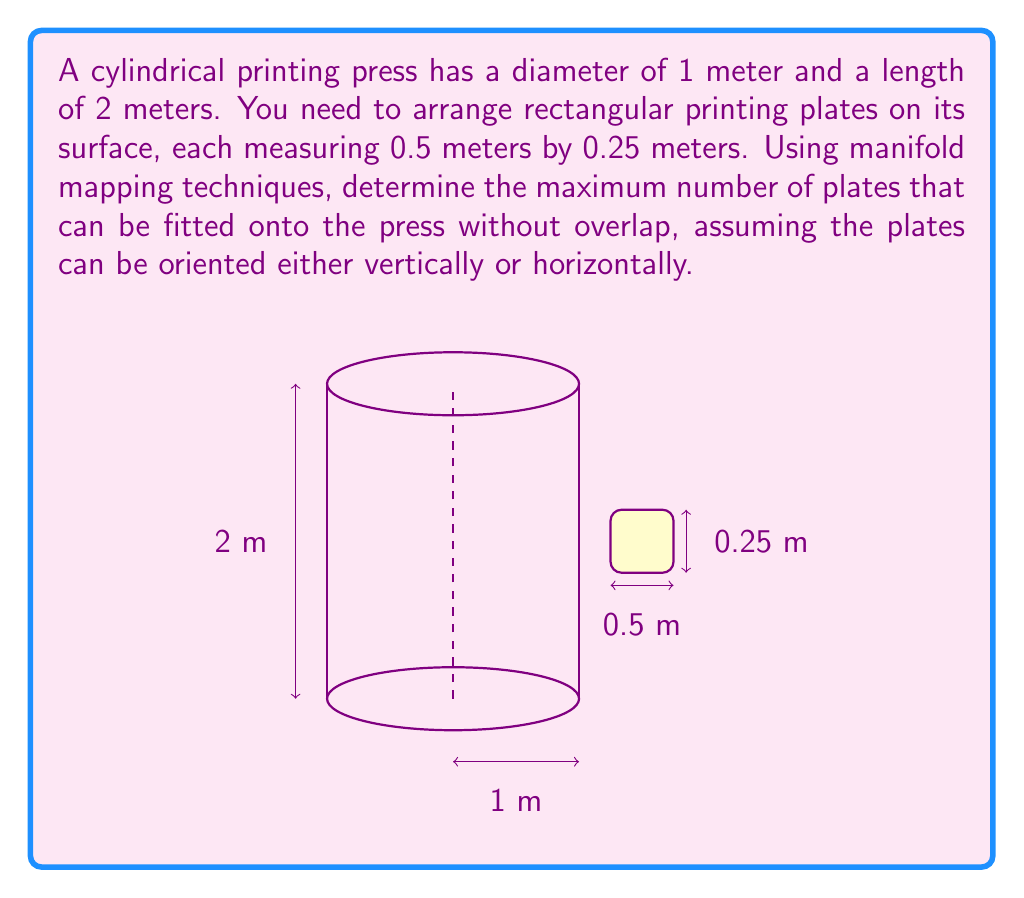Can you solve this math problem? To solve this problem, we'll use manifold mapping techniques to translate the cylindrical surface into a flat rectangular surface. Then, we'll determine the optimal arrangement of plates on this flattened surface.

Step 1: Map the cylindrical surface to a flat rectangle
The surface area of the cylinder is given by:
$$A = 2\pi rh$$
where $r$ is the radius (0.5 m) and $h$ is the height (2 m).

$$A = 2\pi \cdot 0.5 \cdot 2 = 2\pi \text{ m}^2$$

This area can be represented as a rectangle with width equal to the cylinder's circumference and height equal to the cylinder's length:

Width: $w = 2\pi r = 2\pi \cdot 0.5 = \pi \text{ m}$
Height: $h = 2 \text{ m}$

Step 2: Determine possible orientations of plates
Plates can be oriented in two ways:
1. Vertical: 0.25 m wide, 0.5 m tall
2. Horizontal: 0.5 m wide, 0.25 m tall

Step 3: Calculate the number of plates in each orientation
For vertical orientation:
Number across: $\lfloor \frac{\pi}{0.25} \rfloor = \lfloor 12.57 \rfloor = 12$
Number down: $\lfloor \frac{2}{0.5} \rfloor = 4$
Total vertical: $12 \cdot 4 = 48$

For horizontal orientation:
Number across: $\lfloor \frac{\pi}{0.5} \rfloor = \lfloor 6.28 \rfloor = 6$
Number down: $\lfloor \frac{2}{0.25} \rfloor = 8$
Total horizontal: $6 \cdot 8 = 48$

Step 4: Determine the optimal arrangement
Both orientations yield the same number of plates, so either can be chosen as the optimal arrangement.
Answer: 48 plates 